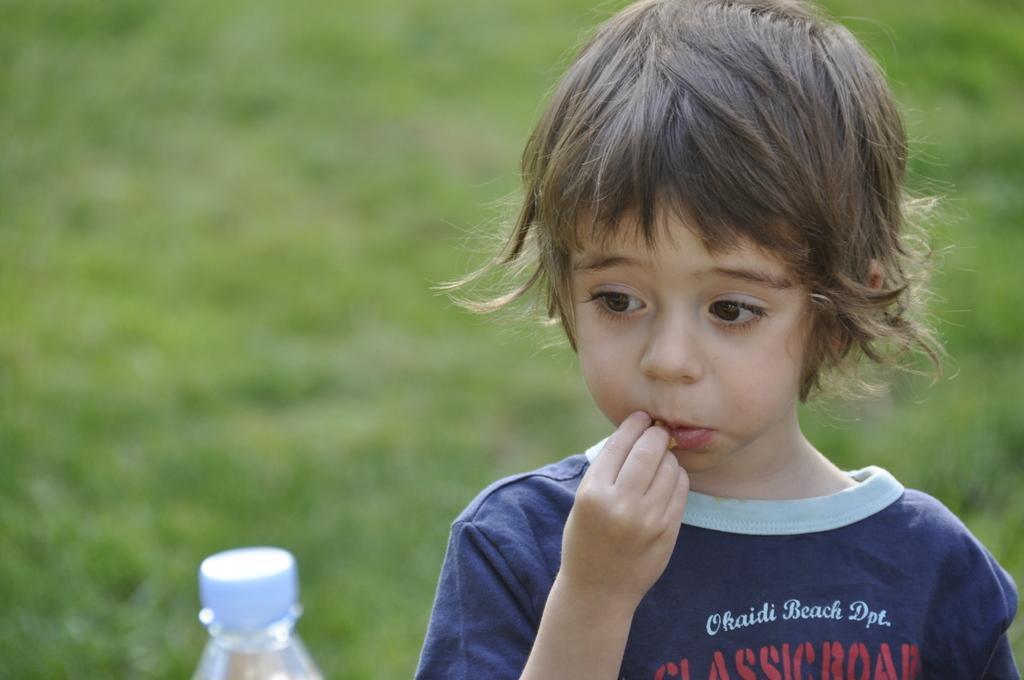How would you summarize this image in a sentence or two? This is the picture of a little boy whose hair is brown in color is standing on the grass and eating something and there is a bottle i front of him. 